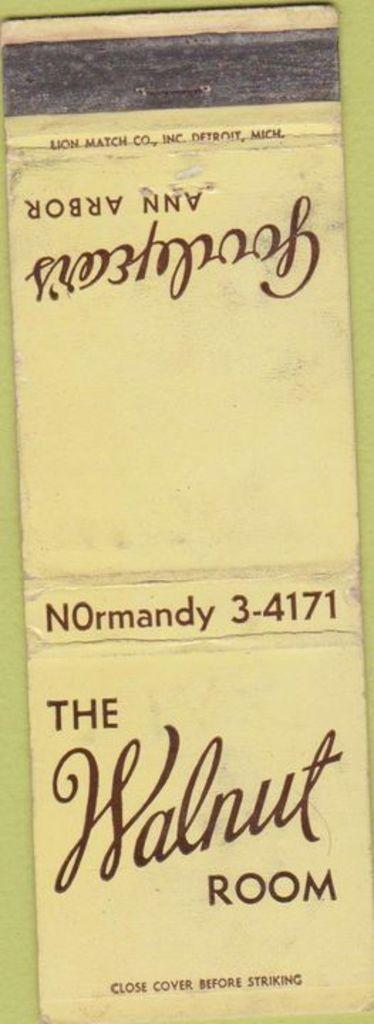<image>
Create a compact narrative representing the image presented. A flattened matchbook from The Walnut Room in Ann Arbor. 